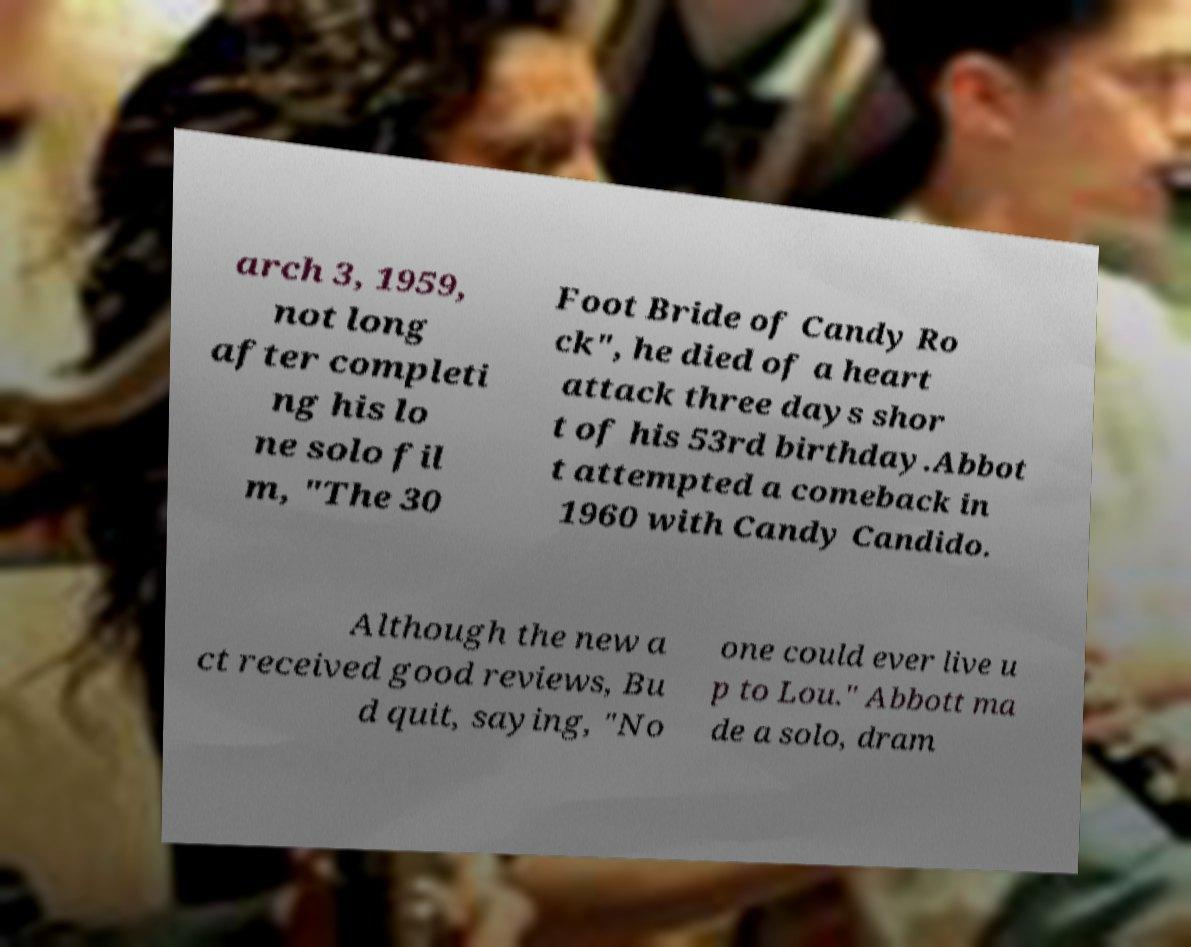There's text embedded in this image that I need extracted. Can you transcribe it verbatim? arch 3, 1959, not long after completi ng his lo ne solo fil m, "The 30 Foot Bride of Candy Ro ck", he died of a heart attack three days shor t of his 53rd birthday.Abbot t attempted a comeback in 1960 with Candy Candido. Although the new a ct received good reviews, Bu d quit, saying, "No one could ever live u p to Lou." Abbott ma de a solo, dram 